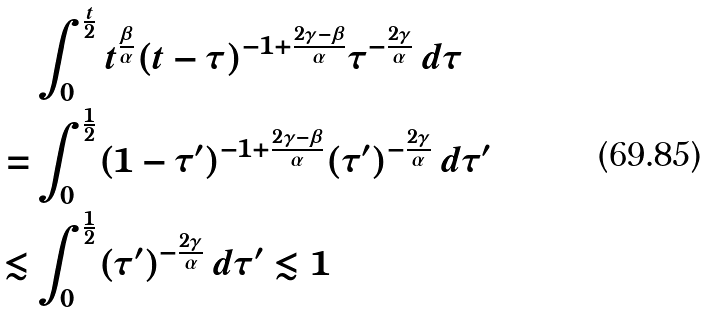Convert formula to latex. <formula><loc_0><loc_0><loc_500><loc_500>& \int _ { 0 } ^ { \frac { t } { 2 } } t ^ { \frac { \beta } { \alpha } } ( t - \tau ) ^ { - 1 + \frac { 2 \gamma - \beta } { \alpha } } \tau ^ { - \frac { 2 \gamma } { \alpha } } \, d \tau \\ = & \int _ { 0 } ^ { \frac { 1 } { 2 } } ( 1 - \tau ^ { \prime } ) ^ { - 1 + \frac { 2 \gamma - \beta } { \alpha } } ( \tau ^ { \prime } ) ^ { - \frac { 2 \gamma } { \alpha } } \, d \tau ^ { \prime } \\ \lesssim & \int _ { 0 } ^ { \frac { 1 } { 2 } } ( \tau ^ { \prime } ) ^ { - \frac { 2 \gamma } { \alpha } } \, d \tau ^ { \prime } \lesssim 1</formula> 